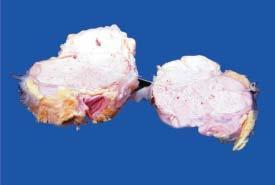re there areas of necrosis in the circumscribed nodular areas?
Answer the question using a single word or phrase. Yes 